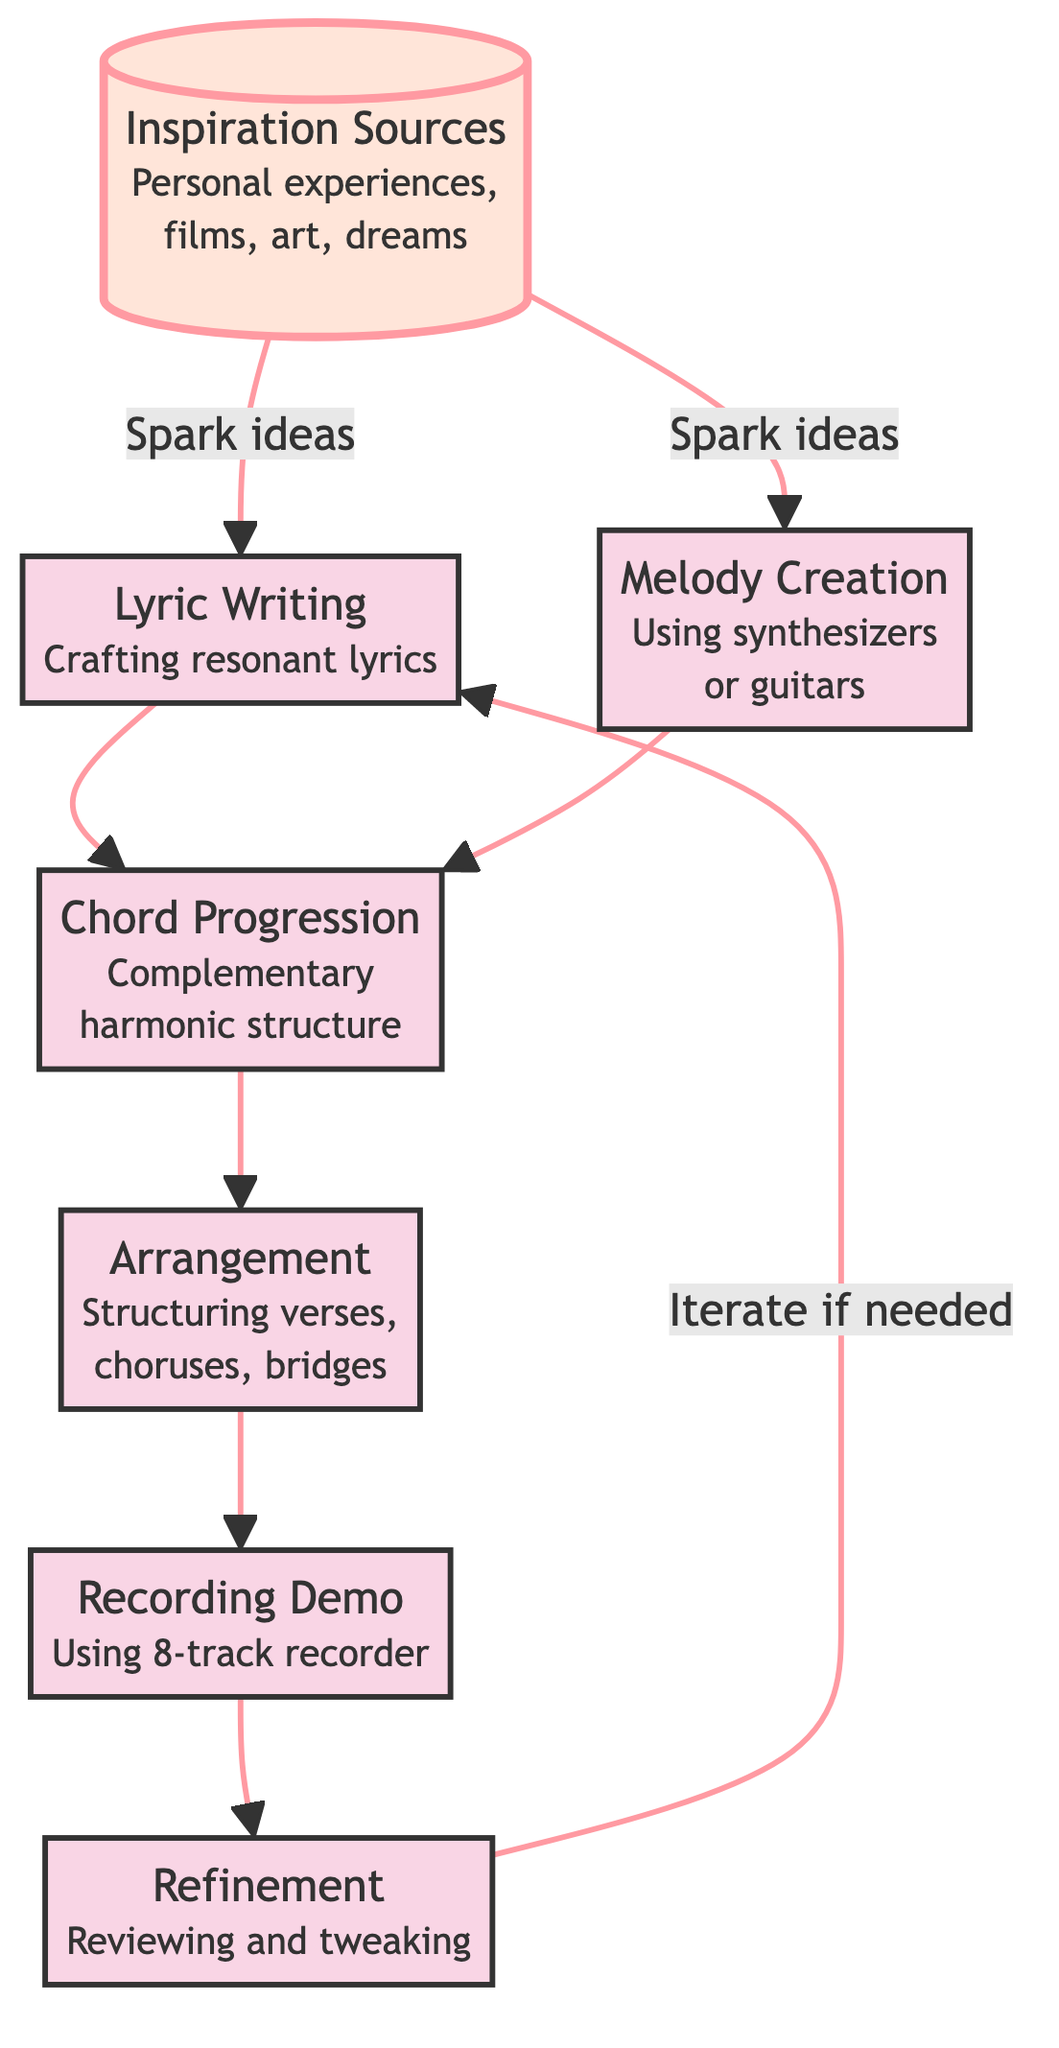What is the starting point of the songwriting process in the diagram? The first node in the flow chart is "Inspiration Sources," which indicates that it is the initial stage where ideas are generated.
Answer: Inspiration Sources How many nodes are there in the diagram? By counting each labeled box in the flow chart, we can find that there are seven distinct nodes representing different stages of the songwriting process.
Answer: 7 What node comes after "Lyric Writing"? In the flow chart, after "Lyric Writing," the next node is "Chord Progression," as indicated by the arrows showing the flow of the process.
Answer: Chord Progression What are the two outputs from "Inspiration Sources"? "Inspiration Sources" leads to both "Lyric Writing" and "Melody Creation," as shown by the arrows branching out from this node.
Answer: Lyric Writing and Melody Creation What is the final stage in the process before looping back? The last node before potentially looping back to "Lyric Writing" for further refinement is "Refinement," where the demo is reviewed and tweaked for better cohesion.
Answer: Refinement How many edges are directed from "Recording Demo" to the next node? There is one directed edge flowing from "Recording Demo" to the next node, which is "Refinement," indicating a single transition in that part of the process.
Answer: 1 What is the purpose of the "Refinement" stage? The purpose of the "Refinement" stage is to review and tweak the demo, ensuring better cohesion and allowing for adjustments before finalizing the songwriting process.
Answer: Review and tweak What happens if changes are needed after "Refinement"? If changes are necessary after the "Refinement" stage, the process allows for iteration back to "Lyric Writing" to make any needed adjustments or improvements.
Answer: Iterate if needed What is a unique feature of the flowchart pertaining to "Inspiration Sources"? "Inspiration Sources" is highlighted, indicating it has a significant role as the starting point that sparks the entire songwriting process.
Answer: Highlighted 